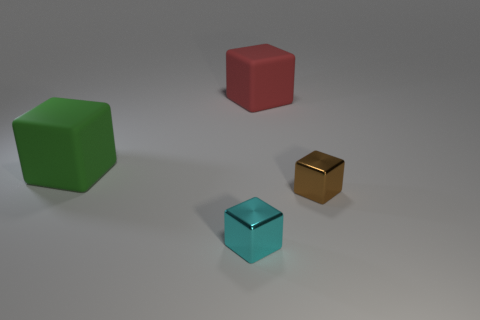Subtract all blue cubes. Subtract all gray balls. How many cubes are left? 4 Add 2 big things. How many objects exist? 6 Subtract 0 purple cylinders. How many objects are left? 4 Subtract all tiny cyan shiny cubes. Subtract all large red cylinders. How many objects are left? 3 Add 1 big rubber cubes. How many big rubber cubes are left? 3 Add 3 purple matte things. How many purple matte things exist? 3 